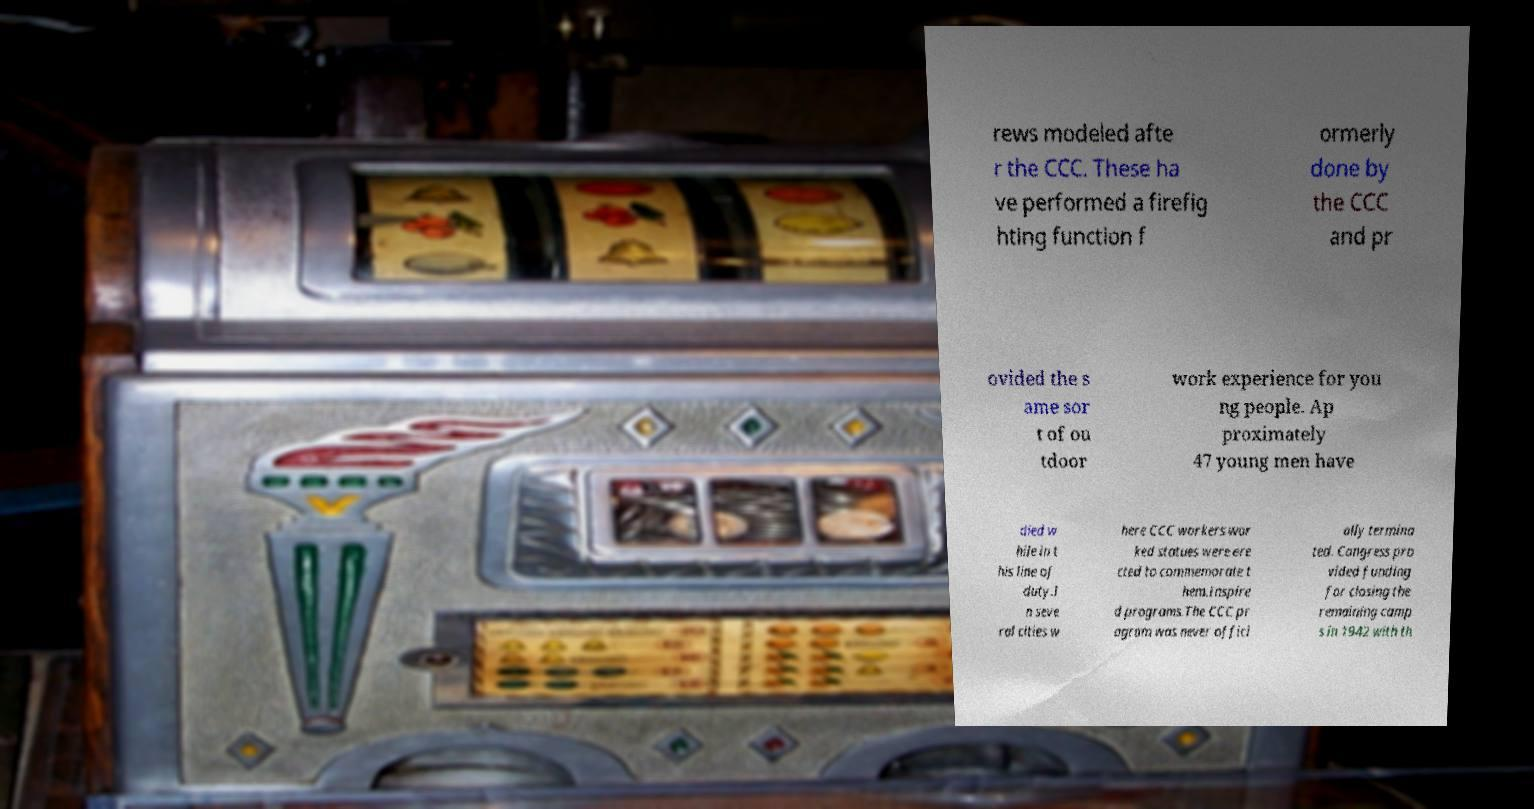Can you accurately transcribe the text from the provided image for me? rews modeled afte r the CCC. These ha ve performed a firefig hting function f ormerly done by the CCC and pr ovided the s ame sor t of ou tdoor work experience for you ng people. Ap proximately 47 young men have died w hile in t his line of duty.I n seve ral cities w here CCC workers wor ked statues were ere cted to commemorate t hem.Inspire d programs.The CCC pr ogram was never offici ally termina ted. Congress pro vided funding for closing the remaining camp s in 1942 with th 